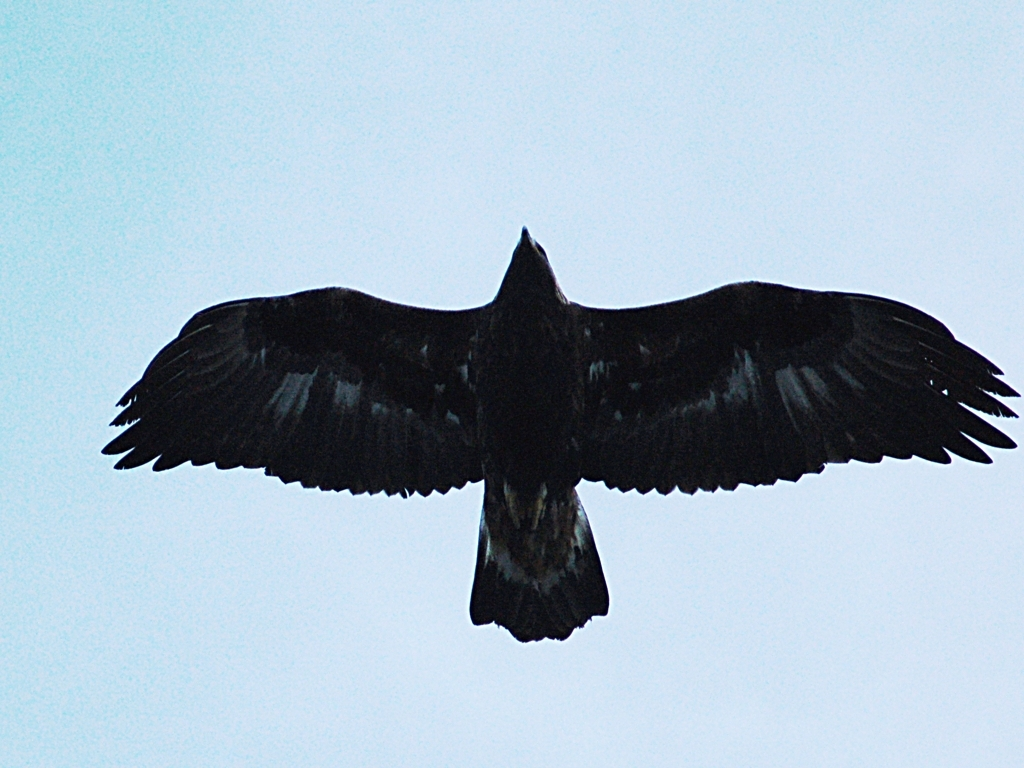Is the image of good quality? While the image clearly captures the subject, a bird in flight with its wings fully extended, the quality is compromised by noticeable graininess and lack of sharp detail, possibly due to low lighting conditions. The silhouette of the bird against the sky indicates it might be dusk or dawn, which would explain the limited light available. 